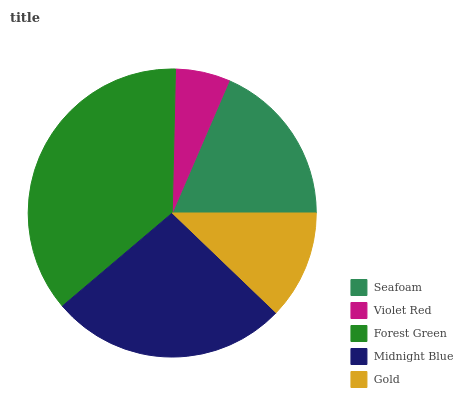Is Violet Red the minimum?
Answer yes or no. Yes. Is Forest Green the maximum?
Answer yes or no. Yes. Is Forest Green the minimum?
Answer yes or no. No. Is Violet Red the maximum?
Answer yes or no. No. Is Forest Green greater than Violet Red?
Answer yes or no. Yes. Is Violet Red less than Forest Green?
Answer yes or no. Yes. Is Violet Red greater than Forest Green?
Answer yes or no. No. Is Forest Green less than Violet Red?
Answer yes or no. No. Is Seafoam the high median?
Answer yes or no. Yes. Is Seafoam the low median?
Answer yes or no. Yes. Is Violet Red the high median?
Answer yes or no. No. Is Forest Green the low median?
Answer yes or no. No. 